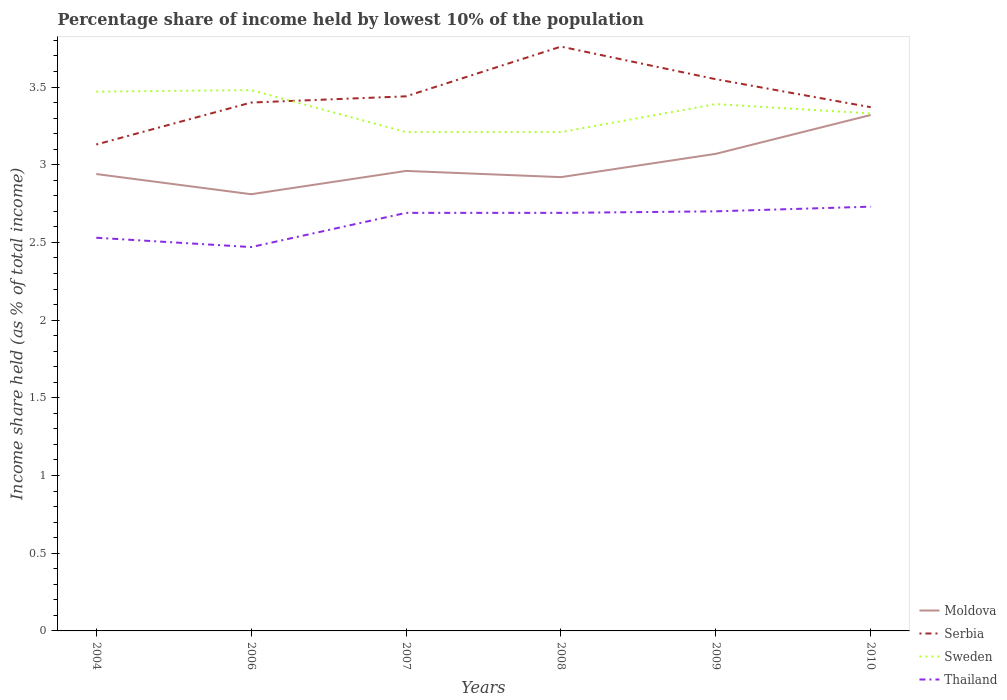Does the line corresponding to Thailand intersect with the line corresponding to Sweden?
Offer a very short reply. No. Across all years, what is the maximum percentage share of income held by lowest 10% of the population in Thailand?
Your answer should be very brief. 2.47. What is the total percentage share of income held by lowest 10% of the population in Serbia in the graph?
Provide a short and direct response. -0.42. What is the difference between the highest and the second highest percentage share of income held by lowest 10% of the population in Sweden?
Provide a succinct answer. 0.27. Is the percentage share of income held by lowest 10% of the population in Sweden strictly greater than the percentage share of income held by lowest 10% of the population in Serbia over the years?
Your answer should be compact. No. What is the difference between two consecutive major ticks on the Y-axis?
Your answer should be very brief. 0.5. Are the values on the major ticks of Y-axis written in scientific E-notation?
Offer a terse response. No. Does the graph contain any zero values?
Your response must be concise. No. Where does the legend appear in the graph?
Provide a succinct answer. Bottom right. What is the title of the graph?
Offer a terse response. Percentage share of income held by lowest 10% of the population. What is the label or title of the X-axis?
Provide a succinct answer. Years. What is the label or title of the Y-axis?
Offer a very short reply. Income share held (as % of total income). What is the Income share held (as % of total income) of Moldova in 2004?
Ensure brevity in your answer.  2.94. What is the Income share held (as % of total income) in Serbia in 2004?
Offer a terse response. 3.13. What is the Income share held (as % of total income) of Sweden in 2004?
Keep it short and to the point. 3.47. What is the Income share held (as % of total income) in Thailand in 2004?
Provide a short and direct response. 2.53. What is the Income share held (as % of total income) in Moldova in 2006?
Provide a succinct answer. 2.81. What is the Income share held (as % of total income) in Serbia in 2006?
Your answer should be very brief. 3.4. What is the Income share held (as % of total income) in Sweden in 2006?
Offer a very short reply. 3.48. What is the Income share held (as % of total income) of Thailand in 2006?
Ensure brevity in your answer.  2.47. What is the Income share held (as % of total income) in Moldova in 2007?
Offer a very short reply. 2.96. What is the Income share held (as % of total income) of Serbia in 2007?
Keep it short and to the point. 3.44. What is the Income share held (as % of total income) of Sweden in 2007?
Ensure brevity in your answer.  3.21. What is the Income share held (as % of total income) in Thailand in 2007?
Offer a very short reply. 2.69. What is the Income share held (as % of total income) in Moldova in 2008?
Keep it short and to the point. 2.92. What is the Income share held (as % of total income) in Serbia in 2008?
Provide a short and direct response. 3.76. What is the Income share held (as % of total income) in Sweden in 2008?
Offer a very short reply. 3.21. What is the Income share held (as % of total income) of Thailand in 2008?
Make the answer very short. 2.69. What is the Income share held (as % of total income) in Moldova in 2009?
Make the answer very short. 3.07. What is the Income share held (as % of total income) in Serbia in 2009?
Provide a succinct answer. 3.55. What is the Income share held (as % of total income) of Sweden in 2009?
Your answer should be compact. 3.39. What is the Income share held (as % of total income) in Moldova in 2010?
Your answer should be very brief. 3.32. What is the Income share held (as % of total income) in Serbia in 2010?
Your answer should be very brief. 3.37. What is the Income share held (as % of total income) in Sweden in 2010?
Provide a short and direct response. 3.33. What is the Income share held (as % of total income) in Thailand in 2010?
Provide a succinct answer. 2.73. Across all years, what is the maximum Income share held (as % of total income) in Moldova?
Keep it short and to the point. 3.32. Across all years, what is the maximum Income share held (as % of total income) of Serbia?
Your answer should be compact. 3.76. Across all years, what is the maximum Income share held (as % of total income) of Sweden?
Give a very brief answer. 3.48. Across all years, what is the maximum Income share held (as % of total income) of Thailand?
Make the answer very short. 2.73. Across all years, what is the minimum Income share held (as % of total income) in Moldova?
Offer a terse response. 2.81. Across all years, what is the minimum Income share held (as % of total income) in Serbia?
Make the answer very short. 3.13. Across all years, what is the minimum Income share held (as % of total income) of Sweden?
Offer a terse response. 3.21. Across all years, what is the minimum Income share held (as % of total income) in Thailand?
Provide a short and direct response. 2.47. What is the total Income share held (as % of total income) of Moldova in the graph?
Offer a very short reply. 18.02. What is the total Income share held (as % of total income) in Serbia in the graph?
Give a very brief answer. 20.65. What is the total Income share held (as % of total income) in Sweden in the graph?
Your answer should be compact. 20.09. What is the total Income share held (as % of total income) of Thailand in the graph?
Keep it short and to the point. 15.81. What is the difference between the Income share held (as % of total income) in Moldova in 2004 and that in 2006?
Make the answer very short. 0.13. What is the difference between the Income share held (as % of total income) of Serbia in 2004 and that in 2006?
Your answer should be compact. -0.27. What is the difference between the Income share held (as % of total income) of Sweden in 2004 and that in 2006?
Make the answer very short. -0.01. What is the difference between the Income share held (as % of total income) in Thailand in 2004 and that in 2006?
Offer a terse response. 0.06. What is the difference between the Income share held (as % of total income) in Moldova in 2004 and that in 2007?
Offer a terse response. -0.02. What is the difference between the Income share held (as % of total income) of Serbia in 2004 and that in 2007?
Your answer should be compact. -0.31. What is the difference between the Income share held (as % of total income) in Sweden in 2004 and that in 2007?
Keep it short and to the point. 0.26. What is the difference between the Income share held (as % of total income) in Thailand in 2004 and that in 2007?
Offer a terse response. -0.16. What is the difference between the Income share held (as % of total income) of Serbia in 2004 and that in 2008?
Provide a succinct answer. -0.63. What is the difference between the Income share held (as % of total income) in Sweden in 2004 and that in 2008?
Make the answer very short. 0.26. What is the difference between the Income share held (as % of total income) of Thailand in 2004 and that in 2008?
Make the answer very short. -0.16. What is the difference between the Income share held (as % of total income) in Moldova in 2004 and that in 2009?
Offer a terse response. -0.13. What is the difference between the Income share held (as % of total income) of Serbia in 2004 and that in 2009?
Offer a very short reply. -0.42. What is the difference between the Income share held (as % of total income) in Sweden in 2004 and that in 2009?
Keep it short and to the point. 0.08. What is the difference between the Income share held (as % of total income) in Thailand in 2004 and that in 2009?
Your answer should be compact. -0.17. What is the difference between the Income share held (as % of total income) in Moldova in 2004 and that in 2010?
Give a very brief answer. -0.38. What is the difference between the Income share held (as % of total income) of Serbia in 2004 and that in 2010?
Your answer should be very brief. -0.24. What is the difference between the Income share held (as % of total income) of Sweden in 2004 and that in 2010?
Make the answer very short. 0.14. What is the difference between the Income share held (as % of total income) in Moldova in 2006 and that in 2007?
Your response must be concise. -0.15. What is the difference between the Income share held (as % of total income) of Serbia in 2006 and that in 2007?
Offer a very short reply. -0.04. What is the difference between the Income share held (as % of total income) in Sweden in 2006 and that in 2007?
Provide a succinct answer. 0.27. What is the difference between the Income share held (as % of total income) in Thailand in 2006 and that in 2007?
Your answer should be very brief. -0.22. What is the difference between the Income share held (as % of total income) in Moldova in 2006 and that in 2008?
Your answer should be very brief. -0.11. What is the difference between the Income share held (as % of total income) in Serbia in 2006 and that in 2008?
Your response must be concise. -0.36. What is the difference between the Income share held (as % of total income) in Sweden in 2006 and that in 2008?
Ensure brevity in your answer.  0.27. What is the difference between the Income share held (as % of total income) in Thailand in 2006 and that in 2008?
Give a very brief answer. -0.22. What is the difference between the Income share held (as % of total income) in Moldova in 2006 and that in 2009?
Keep it short and to the point. -0.26. What is the difference between the Income share held (as % of total income) of Serbia in 2006 and that in 2009?
Offer a terse response. -0.15. What is the difference between the Income share held (as % of total income) of Sweden in 2006 and that in 2009?
Offer a terse response. 0.09. What is the difference between the Income share held (as % of total income) in Thailand in 2006 and that in 2009?
Provide a short and direct response. -0.23. What is the difference between the Income share held (as % of total income) of Moldova in 2006 and that in 2010?
Offer a very short reply. -0.51. What is the difference between the Income share held (as % of total income) of Serbia in 2006 and that in 2010?
Your response must be concise. 0.03. What is the difference between the Income share held (as % of total income) of Sweden in 2006 and that in 2010?
Ensure brevity in your answer.  0.15. What is the difference between the Income share held (as % of total income) of Thailand in 2006 and that in 2010?
Make the answer very short. -0.26. What is the difference between the Income share held (as % of total income) in Moldova in 2007 and that in 2008?
Provide a succinct answer. 0.04. What is the difference between the Income share held (as % of total income) in Serbia in 2007 and that in 2008?
Give a very brief answer. -0.32. What is the difference between the Income share held (as % of total income) in Thailand in 2007 and that in 2008?
Provide a short and direct response. 0. What is the difference between the Income share held (as % of total income) in Moldova in 2007 and that in 2009?
Keep it short and to the point. -0.11. What is the difference between the Income share held (as % of total income) of Serbia in 2007 and that in 2009?
Keep it short and to the point. -0.11. What is the difference between the Income share held (as % of total income) in Sweden in 2007 and that in 2009?
Make the answer very short. -0.18. What is the difference between the Income share held (as % of total income) in Thailand in 2007 and that in 2009?
Provide a short and direct response. -0.01. What is the difference between the Income share held (as % of total income) of Moldova in 2007 and that in 2010?
Offer a very short reply. -0.36. What is the difference between the Income share held (as % of total income) of Serbia in 2007 and that in 2010?
Give a very brief answer. 0.07. What is the difference between the Income share held (as % of total income) of Sweden in 2007 and that in 2010?
Provide a short and direct response. -0.12. What is the difference between the Income share held (as % of total income) of Thailand in 2007 and that in 2010?
Provide a short and direct response. -0.04. What is the difference between the Income share held (as % of total income) of Moldova in 2008 and that in 2009?
Your answer should be compact. -0.15. What is the difference between the Income share held (as % of total income) in Serbia in 2008 and that in 2009?
Make the answer very short. 0.21. What is the difference between the Income share held (as % of total income) of Sweden in 2008 and that in 2009?
Provide a short and direct response. -0.18. What is the difference between the Income share held (as % of total income) in Thailand in 2008 and that in 2009?
Your response must be concise. -0.01. What is the difference between the Income share held (as % of total income) in Moldova in 2008 and that in 2010?
Provide a short and direct response. -0.4. What is the difference between the Income share held (as % of total income) of Serbia in 2008 and that in 2010?
Keep it short and to the point. 0.39. What is the difference between the Income share held (as % of total income) in Sweden in 2008 and that in 2010?
Your answer should be compact. -0.12. What is the difference between the Income share held (as % of total income) in Thailand in 2008 and that in 2010?
Ensure brevity in your answer.  -0.04. What is the difference between the Income share held (as % of total income) in Serbia in 2009 and that in 2010?
Ensure brevity in your answer.  0.18. What is the difference between the Income share held (as % of total income) in Thailand in 2009 and that in 2010?
Make the answer very short. -0.03. What is the difference between the Income share held (as % of total income) of Moldova in 2004 and the Income share held (as % of total income) of Serbia in 2006?
Provide a succinct answer. -0.46. What is the difference between the Income share held (as % of total income) in Moldova in 2004 and the Income share held (as % of total income) in Sweden in 2006?
Make the answer very short. -0.54. What is the difference between the Income share held (as % of total income) in Moldova in 2004 and the Income share held (as % of total income) in Thailand in 2006?
Give a very brief answer. 0.47. What is the difference between the Income share held (as % of total income) of Serbia in 2004 and the Income share held (as % of total income) of Sweden in 2006?
Your answer should be very brief. -0.35. What is the difference between the Income share held (as % of total income) in Serbia in 2004 and the Income share held (as % of total income) in Thailand in 2006?
Give a very brief answer. 0.66. What is the difference between the Income share held (as % of total income) of Sweden in 2004 and the Income share held (as % of total income) of Thailand in 2006?
Provide a short and direct response. 1. What is the difference between the Income share held (as % of total income) of Moldova in 2004 and the Income share held (as % of total income) of Serbia in 2007?
Give a very brief answer. -0.5. What is the difference between the Income share held (as % of total income) in Moldova in 2004 and the Income share held (as % of total income) in Sweden in 2007?
Provide a succinct answer. -0.27. What is the difference between the Income share held (as % of total income) of Moldova in 2004 and the Income share held (as % of total income) of Thailand in 2007?
Ensure brevity in your answer.  0.25. What is the difference between the Income share held (as % of total income) of Serbia in 2004 and the Income share held (as % of total income) of Sweden in 2007?
Give a very brief answer. -0.08. What is the difference between the Income share held (as % of total income) in Serbia in 2004 and the Income share held (as % of total income) in Thailand in 2007?
Your response must be concise. 0.44. What is the difference between the Income share held (as % of total income) of Sweden in 2004 and the Income share held (as % of total income) of Thailand in 2007?
Offer a terse response. 0.78. What is the difference between the Income share held (as % of total income) of Moldova in 2004 and the Income share held (as % of total income) of Serbia in 2008?
Your answer should be very brief. -0.82. What is the difference between the Income share held (as % of total income) in Moldova in 2004 and the Income share held (as % of total income) in Sweden in 2008?
Provide a succinct answer. -0.27. What is the difference between the Income share held (as % of total income) in Moldova in 2004 and the Income share held (as % of total income) in Thailand in 2008?
Your answer should be very brief. 0.25. What is the difference between the Income share held (as % of total income) in Serbia in 2004 and the Income share held (as % of total income) in Sweden in 2008?
Give a very brief answer. -0.08. What is the difference between the Income share held (as % of total income) in Serbia in 2004 and the Income share held (as % of total income) in Thailand in 2008?
Give a very brief answer. 0.44. What is the difference between the Income share held (as % of total income) in Sweden in 2004 and the Income share held (as % of total income) in Thailand in 2008?
Your answer should be very brief. 0.78. What is the difference between the Income share held (as % of total income) of Moldova in 2004 and the Income share held (as % of total income) of Serbia in 2009?
Your response must be concise. -0.61. What is the difference between the Income share held (as % of total income) in Moldova in 2004 and the Income share held (as % of total income) in Sweden in 2009?
Keep it short and to the point. -0.45. What is the difference between the Income share held (as % of total income) of Moldova in 2004 and the Income share held (as % of total income) of Thailand in 2009?
Provide a short and direct response. 0.24. What is the difference between the Income share held (as % of total income) in Serbia in 2004 and the Income share held (as % of total income) in Sweden in 2009?
Your response must be concise. -0.26. What is the difference between the Income share held (as % of total income) in Serbia in 2004 and the Income share held (as % of total income) in Thailand in 2009?
Your answer should be very brief. 0.43. What is the difference between the Income share held (as % of total income) in Sweden in 2004 and the Income share held (as % of total income) in Thailand in 2009?
Offer a terse response. 0.77. What is the difference between the Income share held (as % of total income) of Moldova in 2004 and the Income share held (as % of total income) of Serbia in 2010?
Provide a short and direct response. -0.43. What is the difference between the Income share held (as % of total income) of Moldova in 2004 and the Income share held (as % of total income) of Sweden in 2010?
Your response must be concise. -0.39. What is the difference between the Income share held (as % of total income) of Moldova in 2004 and the Income share held (as % of total income) of Thailand in 2010?
Give a very brief answer. 0.21. What is the difference between the Income share held (as % of total income) in Serbia in 2004 and the Income share held (as % of total income) in Sweden in 2010?
Your response must be concise. -0.2. What is the difference between the Income share held (as % of total income) in Serbia in 2004 and the Income share held (as % of total income) in Thailand in 2010?
Your answer should be very brief. 0.4. What is the difference between the Income share held (as % of total income) of Sweden in 2004 and the Income share held (as % of total income) of Thailand in 2010?
Your answer should be compact. 0.74. What is the difference between the Income share held (as % of total income) in Moldova in 2006 and the Income share held (as % of total income) in Serbia in 2007?
Offer a very short reply. -0.63. What is the difference between the Income share held (as % of total income) in Moldova in 2006 and the Income share held (as % of total income) in Sweden in 2007?
Your answer should be very brief. -0.4. What is the difference between the Income share held (as % of total income) of Moldova in 2006 and the Income share held (as % of total income) of Thailand in 2007?
Your response must be concise. 0.12. What is the difference between the Income share held (as % of total income) of Serbia in 2006 and the Income share held (as % of total income) of Sweden in 2007?
Provide a succinct answer. 0.19. What is the difference between the Income share held (as % of total income) of Serbia in 2006 and the Income share held (as % of total income) of Thailand in 2007?
Provide a short and direct response. 0.71. What is the difference between the Income share held (as % of total income) of Sweden in 2006 and the Income share held (as % of total income) of Thailand in 2007?
Provide a succinct answer. 0.79. What is the difference between the Income share held (as % of total income) in Moldova in 2006 and the Income share held (as % of total income) in Serbia in 2008?
Ensure brevity in your answer.  -0.95. What is the difference between the Income share held (as % of total income) in Moldova in 2006 and the Income share held (as % of total income) in Sweden in 2008?
Keep it short and to the point. -0.4. What is the difference between the Income share held (as % of total income) of Moldova in 2006 and the Income share held (as % of total income) of Thailand in 2008?
Your answer should be compact. 0.12. What is the difference between the Income share held (as % of total income) in Serbia in 2006 and the Income share held (as % of total income) in Sweden in 2008?
Offer a very short reply. 0.19. What is the difference between the Income share held (as % of total income) in Serbia in 2006 and the Income share held (as % of total income) in Thailand in 2008?
Provide a succinct answer. 0.71. What is the difference between the Income share held (as % of total income) in Sweden in 2006 and the Income share held (as % of total income) in Thailand in 2008?
Give a very brief answer. 0.79. What is the difference between the Income share held (as % of total income) of Moldova in 2006 and the Income share held (as % of total income) of Serbia in 2009?
Provide a short and direct response. -0.74. What is the difference between the Income share held (as % of total income) of Moldova in 2006 and the Income share held (as % of total income) of Sweden in 2009?
Ensure brevity in your answer.  -0.58. What is the difference between the Income share held (as % of total income) in Moldova in 2006 and the Income share held (as % of total income) in Thailand in 2009?
Ensure brevity in your answer.  0.11. What is the difference between the Income share held (as % of total income) of Serbia in 2006 and the Income share held (as % of total income) of Sweden in 2009?
Provide a succinct answer. 0.01. What is the difference between the Income share held (as % of total income) of Serbia in 2006 and the Income share held (as % of total income) of Thailand in 2009?
Provide a short and direct response. 0.7. What is the difference between the Income share held (as % of total income) in Sweden in 2006 and the Income share held (as % of total income) in Thailand in 2009?
Keep it short and to the point. 0.78. What is the difference between the Income share held (as % of total income) in Moldova in 2006 and the Income share held (as % of total income) in Serbia in 2010?
Your answer should be compact. -0.56. What is the difference between the Income share held (as % of total income) in Moldova in 2006 and the Income share held (as % of total income) in Sweden in 2010?
Offer a very short reply. -0.52. What is the difference between the Income share held (as % of total income) in Moldova in 2006 and the Income share held (as % of total income) in Thailand in 2010?
Your response must be concise. 0.08. What is the difference between the Income share held (as % of total income) in Serbia in 2006 and the Income share held (as % of total income) in Sweden in 2010?
Ensure brevity in your answer.  0.07. What is the difference between the Income share held (as % of total income) in Serbia in 2006 and the Income share held (as % of total income) in Thailand in 2010?
Your answer should be compact. 0.67. What is the difference between the Income share held (as % of total income) of Sweden in 2006 and the Income share held (as % of total income) of Thailand in 2010?
Provide a short and direct response. 0.75. What is the difference between the Income share held (as % of total income) of Moldova in 2007 and the Income share held (as % of total income) of Sweden in 2008?
Your response must be concise. -0.25. What is the difference between the Income share held (as % of total income) of Moldova in 2007 and the Income share held (as % of total income) of Thailand in 2008?
Offer a very short reply. 0.27. What is the difference between the Income share held (as % of total income) of Serbia in 2007 and the Income share held (as % of total income) of Sweden in 2008?
Your answer should be compact. 0.23. What is the difference between the Income share held (as % of total income) in Serbia in 2007 and the Income share held (as % of total income) in Thailand in 2008?
Your response must be concise. 0.75. What is the difference between the Income share held (as % of total income) in Sweden in 2007 and the Income share held (as % of total income) in Thailand in 2008?
Offer a very short reply. 0.52. What is the difference between the Income share held (as % of total income) of Moldova in 2007 and the Income share held (as % of total income) of Serbia in 2009?
Provide a short and direct response. -0.59. What is the difference between the Income share held (as % of total income) in Moldova in 2007 and the Income share held (as % of total income) in Sweden in 2009?
Keep it short and to the point. -0.43. What is the difference between the Income share held (as % of total income) of Moldova in 2007 and the Income share held (as % of total income) of Thailand in 2009?
Your answer should be compact. 0.26. What is the difference between the Income share held (as % of total income) in Serbia in 2007 and the Income share held (as % of total income) in Thailand in 2009?
Ensure brevity in your answer.  0.74. What is the difference between the Income share held (as % of total income) of Sweden in 2007 and the Income share held (as % of total income) of Thailand in 2009?
Give a very brief answer. 0.51. What is the difference between the Income share held (as % of total income) of Moldova in 2007 and the Income share held (as % of total income) of Serbia in 2010?
Offer a terse response. -0.41. What is the difference between the Income share held (as % of total income) in Moldova in 2007 and the Income share held (as % of total income) in Sweden in 2010?
Keep it short and to the point. -0.37. What is the difference between the Income share held (as % of total income) in Moldova in 2007 and the Income share held (as % of total income) in Thailand in 2010?
Your answer should be compact. 0.23. What is the difference between the Income share held (as % of total income) of Serbia in 2007 and the Income share held (as % of total income) of Sweden in 2010?
Make the answer very short. 0.11. What is the difference between the Income share held (as % of total income) of Serbia in 2007 and the Income share held (as % of total income) of Thailand in 2010?
Ensure brevity in your answer.  0.71. What is the difference between the Income share held (as % of total income) of Sweden in 2007 and the Income share held (as % of total income) of Thailand in 2010?
Provide a short and direct response. 0.48. What is the difference between the Income share held (as % of total income) of Moldova in 2008 and the Income share held (as % of total income) of Serbia in 2009?
Give a very brief answer. -0.63. What is the difference between the Income share held (as % of total income) in Moldova in 2008 and the Income share held (as % of total income) in Sweden in 2009?
Your answer should be very brief. -0.47. What is the difference between the Income share held (as % of total income) in Moldova in 2008 and the Income share held (as % of total income) in Thailand in 2009?
Keep it short and to the point. 0.22. What is the difference between the Income share held (as % of total income) of Serbia in 2008 and the Income share held (as % of total income) of Sweden in 2009?
Offer a terse response. 0.37. What is the difference between the Income share held (as % of total income) of Serbia in 2008 and the Income share held (as % of total income) of Thailand in 2009?
Offer a terse response. 1.06. What is the difference between the Income share held (as % of total income) of Sweden in 2008 and the Income share held (as % of total income) of Thailand in 2009?
Ensure brevity in your answer.  0.51. What is the difference between the Income share held (as % of total income) of Moldova in 2008 and the Income share held (as % of total income) of Serbia in 2010?
Ensure brevity in your answer.  -0.45. What is the difference between the Income share held (as % of total income) of Moldova in 2008 and the Income share held (as % of total income) of Sweden in 2010?
Your response must be concise. -0.41. What is the difference between the Income share held (as % of total income) of Moldova in 2008 and the Income share held (as % of total income) of Thailand in 2010?
Provide a short and direct response. 0.19. What is the difference between the Income share held (as % of total income) in Serbia in 2008 and the Income share held (as % of total income) in Sweden in 2010?
Make the answer very short. 0.43. What is the difference between the Income share held (as % of total income) in Serbia in 2008 and the Income share held (as % of total income) in Thailand in 2010?
Keep it short and to the point. 1.03. What is the difference between the Income share held (as % of total income) of Sweden in 2008 and the Income share held (as % of total income) of Thailand in 2010?
Offer a terse response. 0.48. What is the difference between the Income share held (as % of total income) of Moldova in 2009 and the Income share held (as % of total income) of Sweden in 2010?
Provide a succinct answer. -0.26. What is the difference between the Income share held (as % of total income) in Moldova in 2009 and the Income share held (as % of total income) in Thailand in 2010?
Give a very brief answer. 0.34. What is the difference between the Income share held (as % of total income) of Serbia in 2009 and the Income share held (as % of total income) of Sweden in 2010?
Ensure brevity in your answer.  0.22. What is the difference between the Income share held (as % of total income) in Serbia in 2009 and the Income share held (as % of total income) in Thailand in 2010?
Give a very brief answer. 0.82. What is the difference between the Income share held (as % of total income) in Sweden in 2009 and the Income share held (as % of total income) in Thailand in 2010?
Give a very brief answer. 0.66. What is the average Income share held (as % of total income) of Moldova per year?
Provide a short and direct response. 3. What is the average Income share held (as % of total income) of Serbia per year?
Give a very brief answer. 3.44. What is the average Income share held (as % of total income) in Sweden per year?
Offer a very short reply. 3.35. What is the average Income share held (as % of total income) of Thailand per year?
Ensure brevity in your answer.  2.63. In the year 2004, what is the difference between the Income share held (as % of total income) of Moldova and Income share held (as % of total income) of Serbia?
Your answer should be very brief. -0.19. In the year 2004, what is the difference between the Income share held (as % of total income) of Moldova and Income share held (as % of total income) of Sweden?
Your answer should be very brief. -0.53. In the year 2004, what is the difference between the Income share held (as % of total income) of Moldova and Income share held (as % of total income) of Thailand?
Your answer should be very brief. 0.41. In the year 2004, what is the difference between the Income share held (as % of total income) in Serbia and Income share held (as % of total income) in Sweden?
Make the answer very short. -0.34. In the year 2006, what is the difference between the Income share held (as % of total income) in Moldova and Income share held (as % of total income) in Serbia?
Your answer should be very brief. -0.59. In the year 2006, what is the difference between the Income share held (as % of total income) of Moldova and Income share held (as % of total income) of Sweden?
Ensure brevity in your answer.  -0.67. In the year 2006, what is the difference between the Income share held (as % of total income) in Moldova and Income share held (as % of total income) in Thailand?
Your response must be concise. 0.34. In the year 2006, what is the difference between the Income share held (as % of total income) of Serbia and Income share held (as % of total income) of Sweden?
Offer a terse response. -0.08. In the year 2007, what is the difference between the Income share held (as % of total income) in Moldova and Income share held (as % of total income) in Serbia?
Your response must be concise. -0.48. In the year 2007, what is the difference between the Income share held (as % of total income) in Moldova and Income share held (as % of total income) in Sweden?
Your response must be concise. -0.25. In the year 2007, what is the difference between the Income share held (as % of total income) of Moldova and Income share held (as % of total income) of Thailand?
Offer a very short reply. 0.27. In the year 2007, what is the difference between the Income share held (as % of total income) of Serbia and Income share held (as % of total income) of Sweden?
Offer a terse response. 0.23. In the year 2007, what is the difference between the Income share held (as % of total income) in Sweden and Income share held (as % of total income) in Thailand?
Provide a short and direct response. 0.52. In the year 2008, what is the difference between the Income share held (as % of total income) in Moldova and Income share held (as % of total income) in Serbia?
Keep it short and to the point. -0.84. In the year 2008, what is the difference between the Income share held (as % of total income) in Moldova and Income share held (as % of total income) in Sweden?
Offer a terse response. -0.29. In the year 2008, what is the difference between the Income share held (as % of total income) in Moldova and Income share held (as % of total income) in Thailand?
Keep it short and to the point. 0.23. In the year 2008, what is the difference between the Income share held (as % of total income) in Serbia and Income share held (as % of total income) in Sweden?
Your answer should be very brief. 0.55. In the year 2008, what is the difference between the Income share held (as % of total income) of Serbia and Income share held (as % of total income) of Thailand?
Provide a short and direct response. 1.07. In the year 2008, what is the difference between the Income share held (as % of total income) of Sweden and Income share held (as % of total income) of Thailand?
Your answer should be compact. 0.52. In the year 2009, what is the difference between the Income share held (as % of total income) in Moldova and Income share held (as % of total income) in Serbia?
Give a very brief answer. -0.48. In the year 2009, what is the difference between the Income share held (as % of total income) of Moldova and Income share held (as % of total income) of Sweden?
Keep it short and to the point. -0.32. In the year 2009, what is the difference between the Income share held (as % of total income) in Moldova and Income share held (as % of total income) in Thailand?
Provide a succinct answer. 0.37. In the year 2009, what is the difference between the Income share held (as % of total income) of Serbia and Income share held (as % of total income) of Sweden?
Make the answer very short. 0.16. In the year 2009, what is the difference between the Income share held (as % of total income) of Serbia and Income share held (as % of total income) of Thailand?
Provide a short and direct response. 0.85. In the year 2009, what is the difference between the Income share held (as % of total income) of Sweden and Income share held (as % of total income) of Thailand?
Your answer should be compact. 0.69. In the year 2010, what is the difference between the Income share held (as % of total income) in Moldova and Income share held (as % of total income) in Sweden?
Make the answer very short. -0.01. In the year 2010, what is the difference between the Income share held (as % of total income) in Moldova and Income share held (as % of total income) in Thailand?
Offer a terse response. 0.59. In the year 2010, what is the difference between the Income share held (as % of total income) in Serbia and Income share held (as % of total income) in Thailand?
Ensure brevity in your answer.  0.64. In the year 2010, what is the difference between the Income share held (as % of total income) in Sweden and Income share held (as % of total income) in Thailand?
Your answer should be very brief. 0.6. What is the ratio of the Income share held (as % of total income) of Moldova in 2004 to that in 2006?
Your answer should be very brief. 1.05. What is the ratio of the Income share held (as % of total income) of Serbia in 2004 to that in 2006?
Keep it short and to the point. 0.92. What is the ratio of the Income share held (as % of total income) of Thailand in 2004 to that in 2006?
Provide a short and direct response. 1.02. What is the ratio of the Income share held (as % of total income) in Moldova in 2004 to that in 2007?
Give a very brief answer. 0.99. What is the ratio of the Income share held (as % of total income) in Serbia in 2004 to that in 2007?
Make the answer very short. 0.91. What is the ratio of the Income share held (as % of total income) in Sweden in 2004 to that in 2007?
Offer a terse response. 1.08. What is the ratio of the Income share held (as % of total income) of Thailand in 2004 to that in 2007?
Offer a very short reply. 0.94. What is the ratio of the Income share held (as % of total income) in Moldova in 2004 to that in 2008?
Make the answer very short. 1.01. What is the ratio of the Income share held (as % of total income) in Serbia in 2004 to that in 2008?
Your response must be concise. 0.83. What is the ratio of the Income share held (as % of total income) in Sweden in 2004 to that in 2008?
Your answer should be compact. 1.08. What is the ratio of the Income share held (as % of total income) in Thailand in 2004 to that in 2008?
Give a very brief answer. 0.94. What is the ratio of the Income share held (as % of total income) in Moldova in 2004 to that in 2009?
Give a very brief answer. 0.96. What is the ratio of the Income share held (as % of total income) in Serbia in 2004 to that in 2009?
Provide a short and direct response. 0.88. What is the ratio of the Income share held (as % of total income) of Sweden in 2004 to that in 2009?
Keep it short and to the point. 1.02. What is the ratio of the Income share held (as % of total income) in Thailand in 2004 to that in 2009?
Your answer should be very brief. 0.94. What is the ratio of the Income share held (as % of total income) in Moldova in 2004 to that in 2010?
Your answer should be compact. 0.89. What is the ratio of the Income share held (as % of total income) of Serbia in 2004 to that in 2010?
Offer a very short reply. 0.93. What is the ratio of the Income share held (as % of total income) of Sweden in 2004 to that in 2010?
Offer a very short reply. 1.04. What is the ratio of the Income share held (as % of total income) of Thailand in 2004 to that in 2010?
Provide a succinct answer. 0.93. What is the ratio of the Income share held (as % of total income) of Moldova in 2006 to that in 2007?
Provide a succinct answer. 0.95. What is the ratio of the Income share held (as % of total income) in Serbia in 2006 to that in 2007?
Your answer should be very brief. 0.99. What is the ratio of the Income share held (as % of total income) in Sweden in 2006 to that in 2007?
Ensure brevity in your answer.  1.08. What is the ratio of the Income share held (as % of total income) in Thailand in 2006 to that in 2007?
Your response must be concise. 0.92. What is the ratio of the Income share held (as % of total income) in Moldova in 2006 to that in 2008?
Your answer should be compact. 0.96. What is the ratio of the Income share held (as % of total income) of Serbia in 2006 to that in 2008?
Make the answer very short. 0.9. What is the ratio of the Income share held (as % of total income) of Sweden in 2006 to that in 2008?
Ensure brevity in your answer.  1.08. What is the ratio of the Income share held (as % of total income) in Thailand in 2006 to that in 2008?
Your answer should be compact. 0.92. What is the ratio of the Income share held (as % of total income) in Moldova in 2006 to that in 2009?
Make the answer very short. 0.92. What is the ratio of the Income share held (as % of total income) in Serbia in 2006 to that in 2009?
Offer a very short reply. 0.96. What is the ratio of the Income share held (as % of total income) in Sweden in 2006 to that in 2009?
Your response must be concise. 1.03. What is the ratio of the Income share held (as % of total income) in Thailand in 2006 to that in 2009?
Your answer should be very brief. 0.91. What is the ratio of the Income share held (as % of total income) in Moldova in 2006 to that in 2010?
Your answer should be very brief. 0.85. What is the ratio of the Income share held (as % of total income) in Serbia in 2006 to that in 2010?
Offer a very short reply. 1.01. What is the ratio of the Income share held (as % of total income) of Sweden in 2006 to that in 2010?
Your response must be concise. 1.04. What is the ratio of the Income share held (as % of total income) in Thailand in 2006 to that in 2010?
Your answer should be very brief. 0.9. What is the ratio of the Income share held (as % of total income) of Moldova in 2007 to that in 2008?
Your response must be concise. 1.01. What is the ratio of the Income share held (as % of total income) of Serbia in 2007 to that in 2008?
Make the answer very short. 0.91. What is the ratio of the Income share held (as % of total income) in Sweden in 2007 to that in 2008?
Your answer should be compact. 1. What is the ratio of the Income share held (as % of total income) in Thailand in 2007 to that in 2008?
Provide a succinct answer. 1. What is the ratio of the Income share held (as % of total income) in Moldova in 2007 to that in 2009?
Keep it short and to the point. 0.96. What is the ratio of the Income share held (as % of total income) of Serbia in 2007 to that in 2009?
Ensure brevity in your answer.  0.97. What is the ratio of the Income share held (as % of total income) in Sweden in 2007 to that in 2009?
Make the answer very short. 0.95. What is the ratio of the Income share held (as % of total income) in Moldova in 2007 to that in 2010?
Your answer should be very brief. 0.89. What is the ratio of the Income share held (as % of total income) of Serbia in 2007 to that in 2010?
Make the answer very short. 1.02. What is the ratio of the Income share held (as % of total income) in Thailand in 2007 to that in 2010?
Make the answer very short. 0.99. What is the ratio of the Income share held (as % of total income) of Moldova in 2008 to that in 2009?
Offer a terse response. 0.95. What is the ratio of the Income share held (as % of total income) of Serbia in 2008 to that in 2009?
Make the answer very short. 1.06. What is the ratio of the Income share held (as % of total income) in Sweden in 2008 to that in 2009?
Your answer should be compact. 0.95. What is the ratio of the Income share held (as % of total income) of Moldova in 2008 to that in 2010?
Keep it short and to the point. 0.88. What is the ratio of the Income share held (as % of total income) of Serbia in 2008 to that in 2010?
Your answer should be very brief. 1.12. What is the ratio of the Income share held (as % of total income) of Thailand in 2008 to that in 2010?
Offer a terse response. 0.99. What is the ratio of the Income share held (as % of total income) of Moldova in 2009 to that in 2010?
Provide a succinct answer. 0.92. What is the ratio of the Income share held (as % of total income) in Serbia in 2009 to that in 2010?
Your response must be concise. 1.05. What is the ratio of the Income share held (as % of total income) in Sweden in 2009 to that in 2010?
Offer a very short reply. 1.02. What is the ratio of the Income share held (as % of total income) of Thailand in 2009 to that in 2010?
Provide a succinct answer. 0.99. What is the difference between the highest and the second highest Income share held (as % of total income) of Serbia?
Offer a very short reply. 0.21. What is the difference between the highest and the second highest Income share held (as % of total income) in Sweden?
Provide a succinct answer. 0.01. What is the difference between the highest and the second highest Income share held (as % of total income) in Thailand?
Your answer should be compact. 0.03. What is the difference between the highest and the lowest Income share held (as % of total income) in Moldova?
Give a very brief answer. 0.51. What is the difference between the highest and the lowest Income share held (as % of total income) of Serbia?
Offer a very short reply. 0.63. What is the difference between the highest and the lowest Income share held (as % of total income) in Sweden?
Offer a terse response. 0.27. What is the difference between the highest and the lowest Income share held (as % of total income) of Thailand?
Your response must be concise. 0.26. 